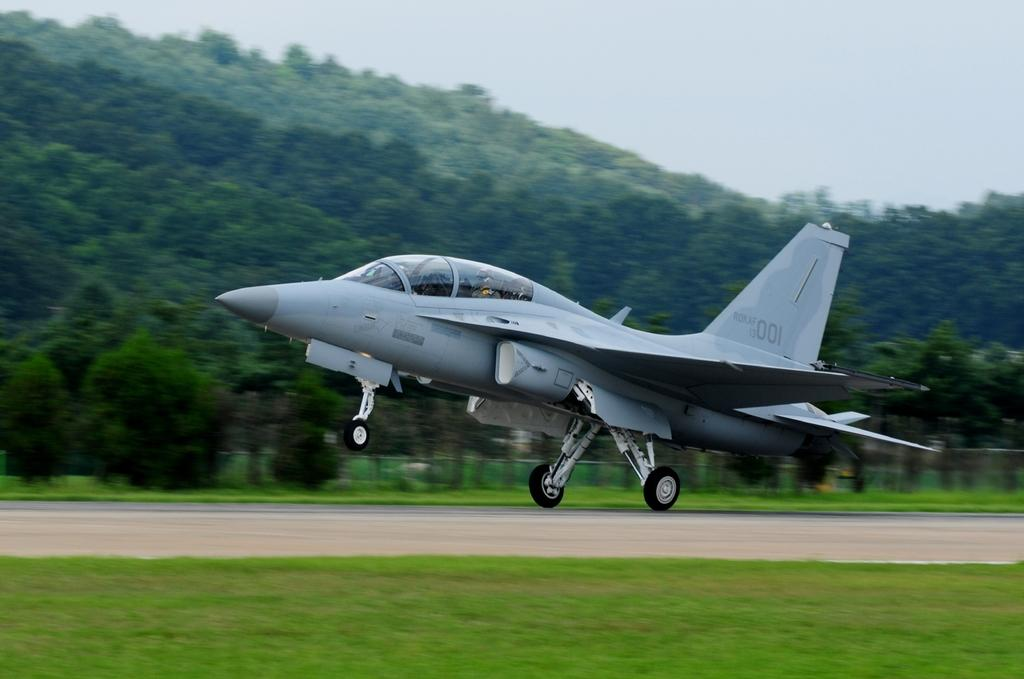<image>
Render a clear and concise summary of the photo. Gray airplane getting ready to take off with the numbers 001 on it's tail. 